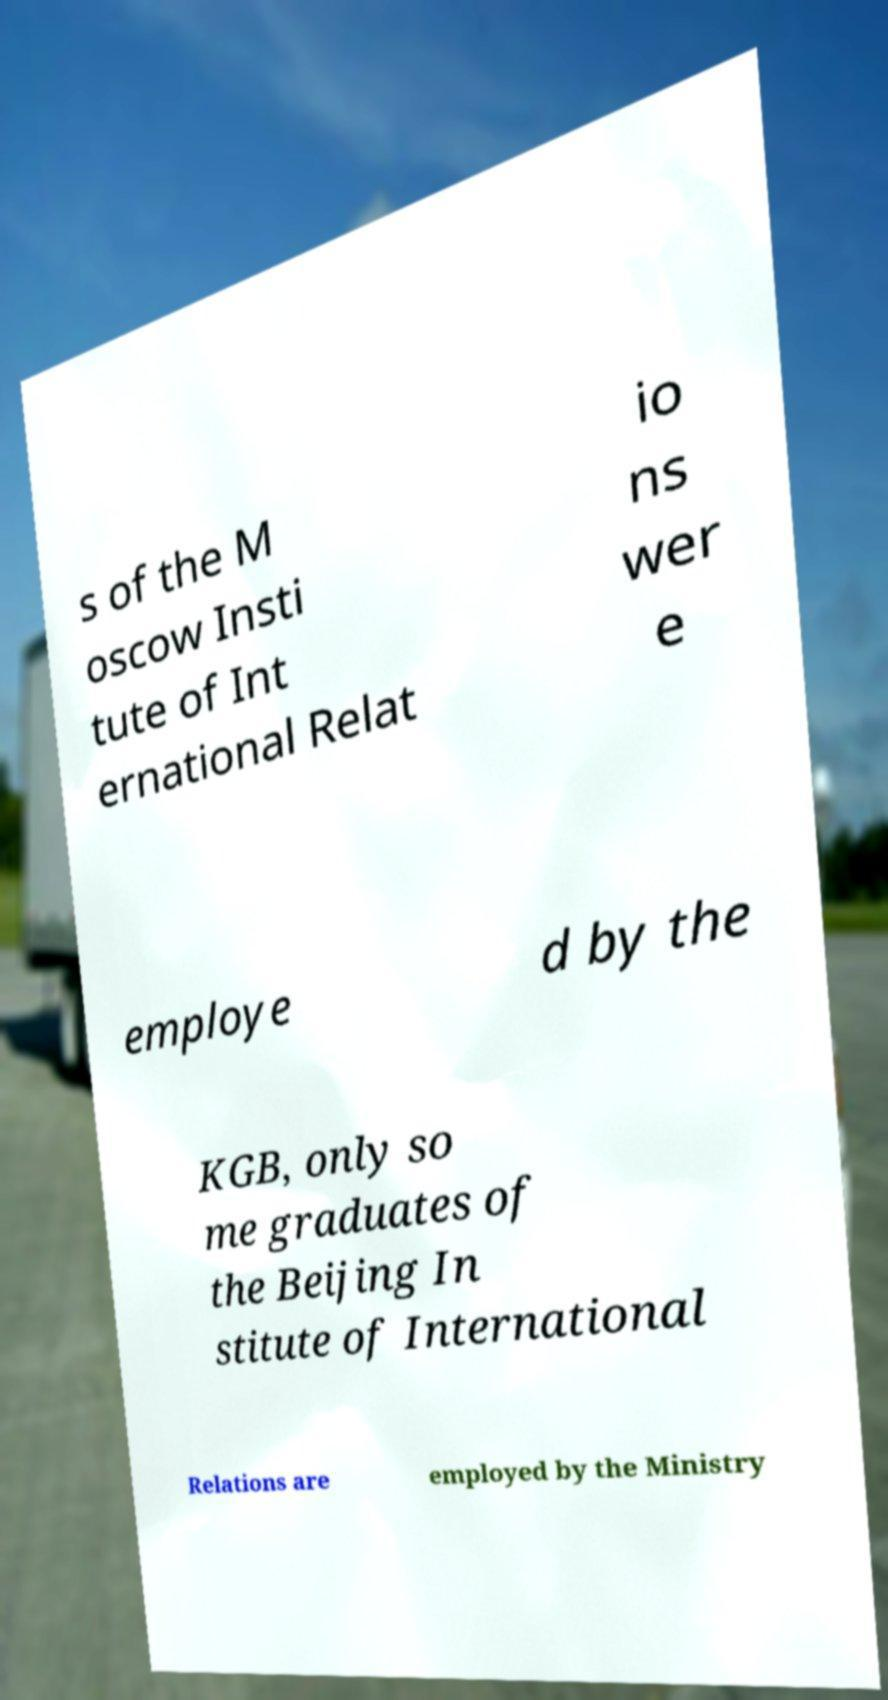I need the written content from this picture converted into text. Can you do that? s of the M oscow Insti tute of Int ernational Relat io ns wer e employe d by the KGB, only so me graduates of the Beijing In stitute of International Relations are employed by the Ministry 